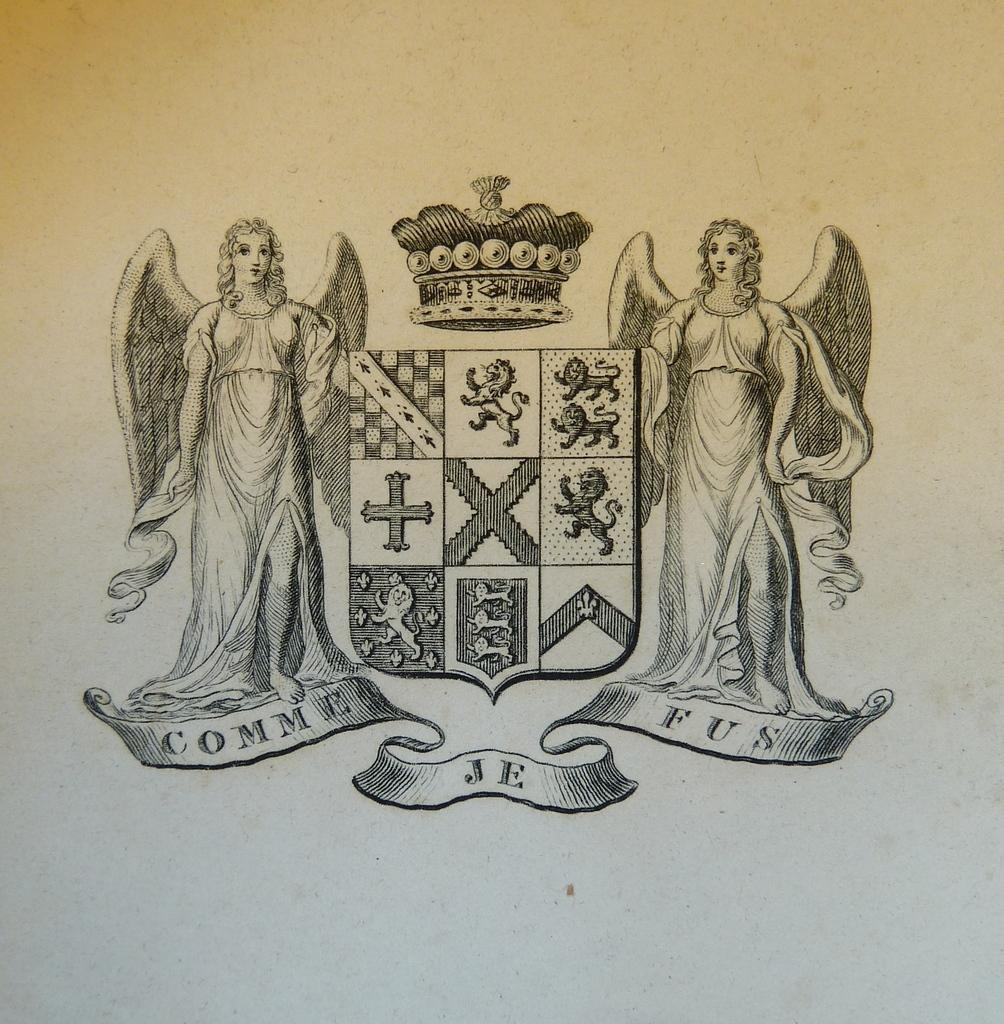What is the main subject of the sketch in the image? The sketch on the white surface features two people. Are there any objects or accessories in the sketch? Yes, a crown is present in the sketch. What else can be observed in the sketch? There are symbols in the sketch. How many pizzas are being delivered in the alley depicted in the image? There is no alley or pizza delivery present in the image; it features a sketch with two people, a crown, and symbols. 